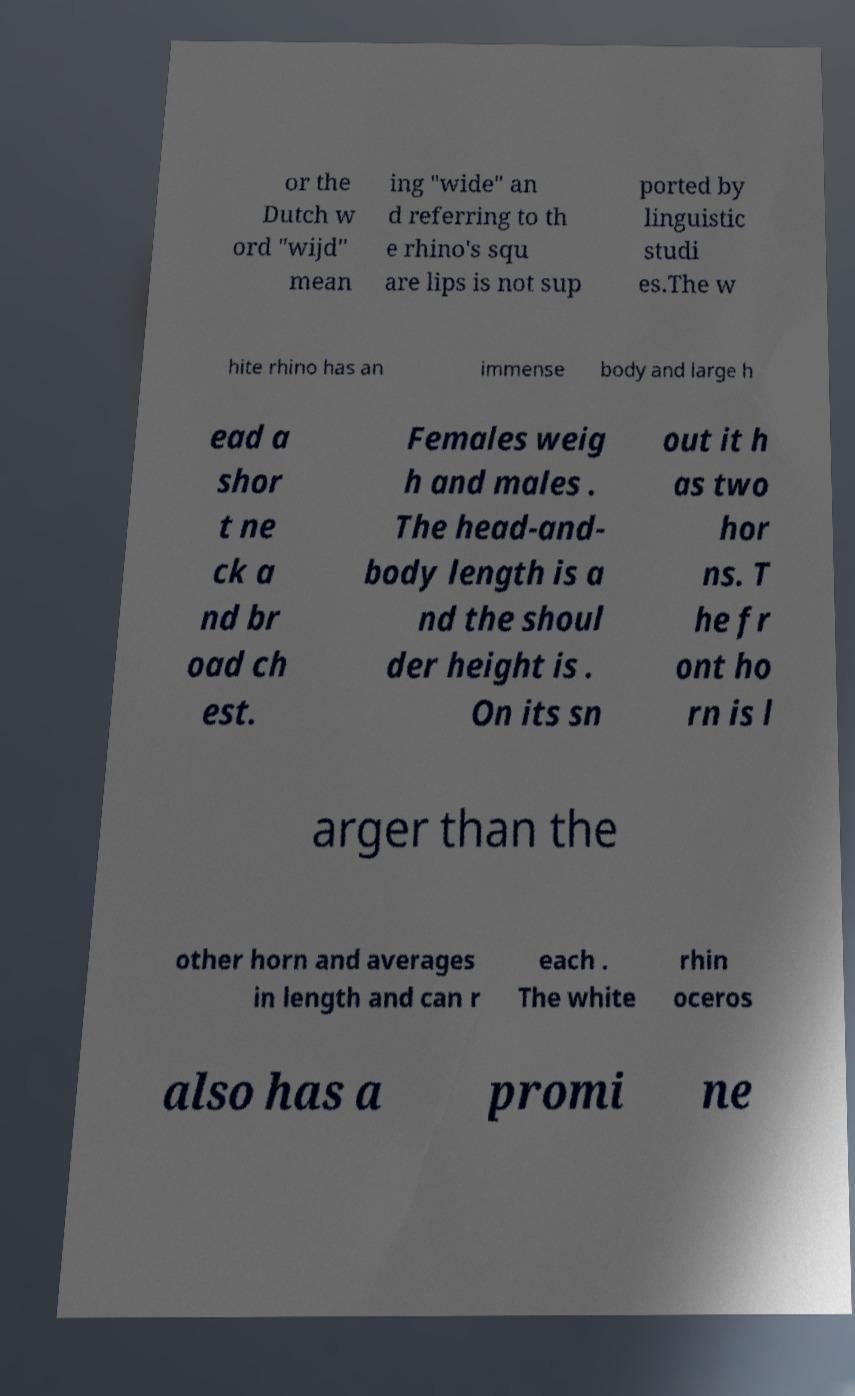What messages or text are displayed in this image? I need them in a readable, typed format. or the Dutch w ord "wijd" mean ing "wide" an d referring to th e rhino's squ are lips is not sup ported by linguistic studi es.The w hite rhino has an immense body and large h ead a shor t ne ck a nd br oad ch est. Females weig h and males . The head-and- body length is a nd the shoul der height is . On its sn out it h as two hor ns. T he fr ont ho rn is l arger than the other horn and averages in length and can r each . The white rhin oceros also has a promi ne 